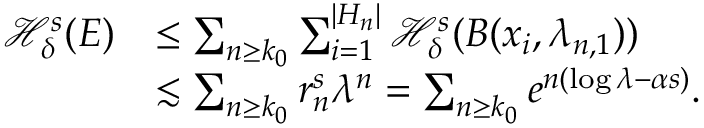Convert formula to latex. <formula><loc_0><loc_0><loc_500><loc_500>\begin{array} { r l } { \mathcal { H } _ { \delta } ^ { s } ( E ) } & { \leq \sum _ { n \geq k _ { 0 } } \sum _ { i = 1 } ^ { | H _ { n } | } \mathcal { H } _ { \delta } ^ { s } ( B ( x _ { i } , \lambda _ { n , 1 } ) ) } \\ & { \lesssim \sum _ { n \geq k _ { 0 } } r _ { n } ^ { s } \lambda ^ { n } = \sum _ { n \geq k _ { 0 } } e ^ { n ( \log \lambda - \alpha s ) } . } \end{array}</formula> 